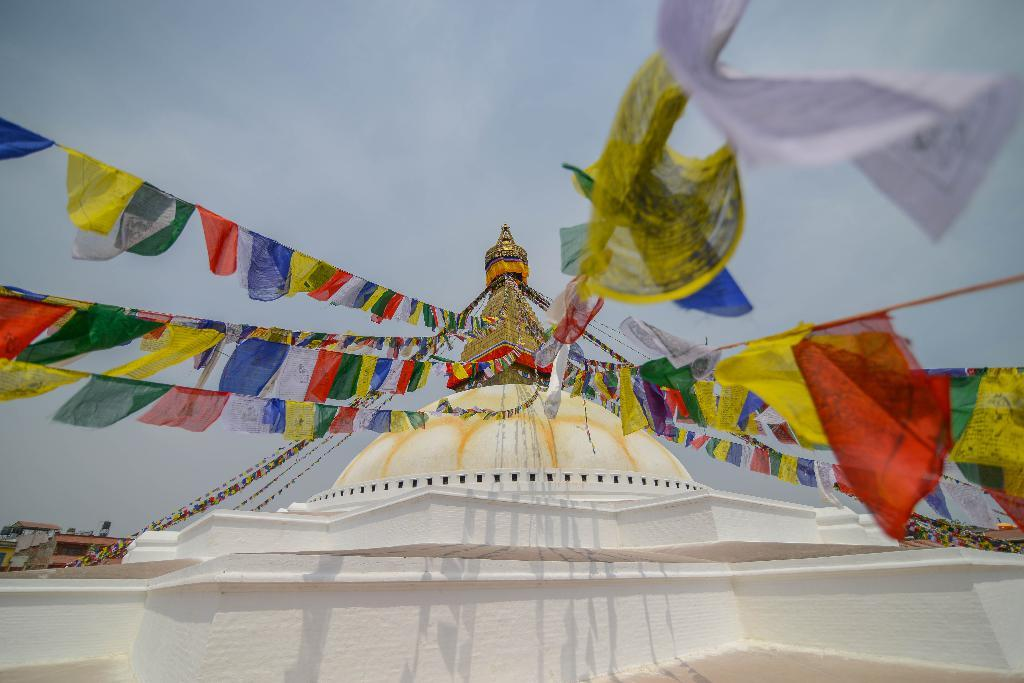What type of structure is visible in the image? There is a wall with a roof in the image. What is attached to the roof of the structure? Colorful decorative flags are attached to the roof with rope. What can be seen at the top of the image? The sky is visible at the top of the image. What language is spoken by the cub in the image? There is no cub present in the image, and therefore no language can be attributed to it. 